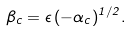<formula> <loc_0><loc_0><loc_500><loc_500>\beta _ { c } = \epsilon \, ( - \alpha _ { c } ) ^ { 1 / 2 } .</formula> 